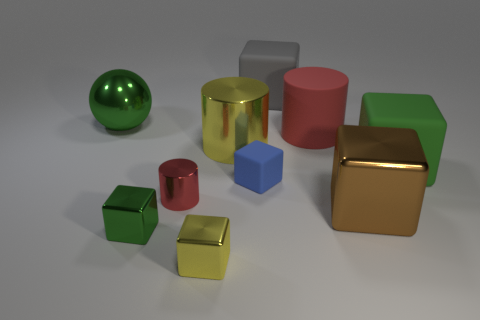Subtract all green metallic cubes. How many cubes are left? 5 Subtract all yellow cubes. How many cubes are left? 5 Subtract all red blocks. Subtract all gray balls. How many blocks are left? 6 Subtract all spheres. How many objects are left? 9 Add 4 small brown matte things. How many small brown matte things exist? 4 Subtract 0 red balls. How many objects are left? 10 Subtract all tiny yellow spheres. Subtract all large metallic balls. How many objects are left? 9 Add 3 tiny green metal blocks. How many tiny green metal blocks are left? 4 